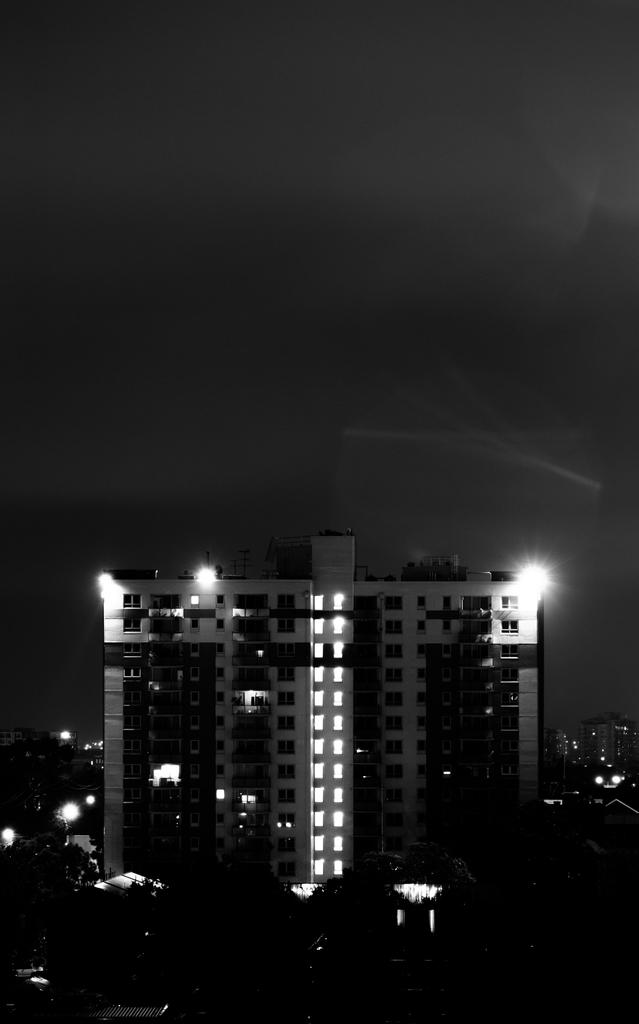What is the color scheme of the image? The image is black and white. What type of natural elements can be seen in the image? There are trees in the image. What type of man-made structures are present in the image? There are buildings in the image. What type of illumination is visible in the image? There are lights in the image. What can be seen in the background of the image? The sky is visible in the background of the image. What type of muscle is being flexed by the person in the image? There is no person present in the image, so it is not possible to determine if any muscles are being flexed. 